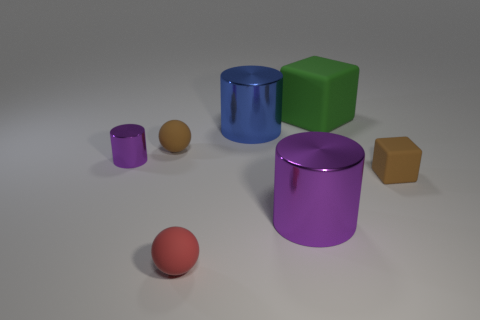Add 2 tiny brown matte things. How many objects exist? 9 Subtract all spheres. How many objects are left? 5 Subtract all big blue objects. Subtract all large purple shiny cylinders. How many objects are left? 5 Add 4 brown matte things. How many brown matte things are left? 6 Add 2 large brown cubes. How many large brown cubes exist? 2 Subtract 1 purple cylinders. How many objects are left? 6 